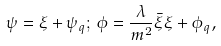Convert formula to latex. <formula><loc_0><loc_0><loc_500><loc_500>\psi = \xi + \psi _ { q } ; \, \phi = \frac { \lambda } { m ^ { 2 } } \bar { \xi } \xi + \phi _ { q } ,</formula> 